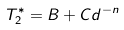<formula> <loc_0><loc_0><loc_500><loc_500>T _ { 2 } ^ { * } = B + C d ^ { - n }</formula> 